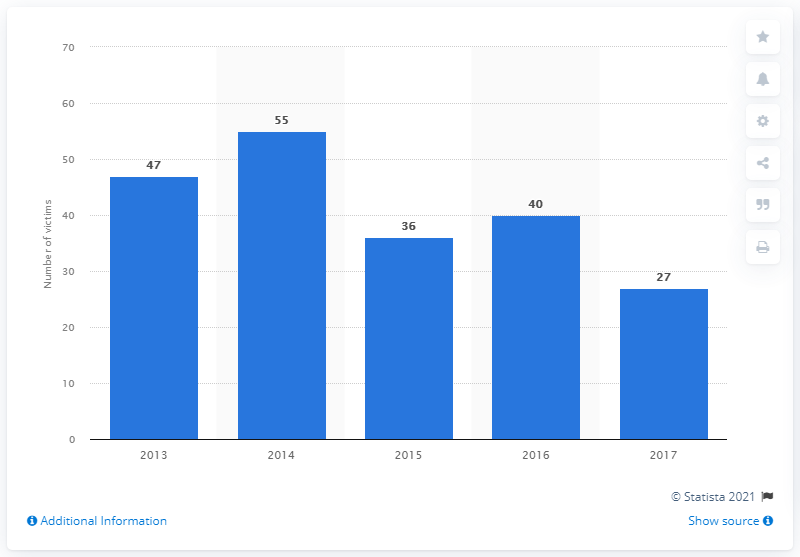Give some essential details in this illustration. On New Year's Eve and New Year's Day in 2013, 40 people died in traffic accidents. On New Year's Eve and New Year's Day in 2017, there were 27 deaths due to traffic accidents in Brazil. 